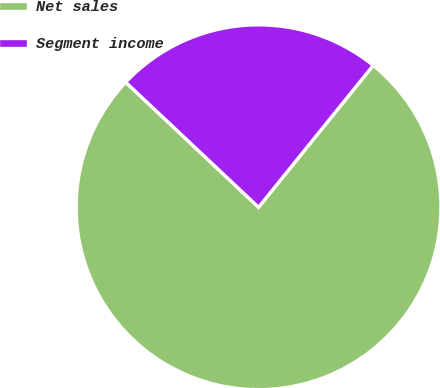Convert chart. <chart><loc_0><loc_0><loc_500><loc_500><pie_chart><fcel>Net sales<fcel>Segment income<nl><fcel>76.2%<fcel>23.8%<nl></chart> 